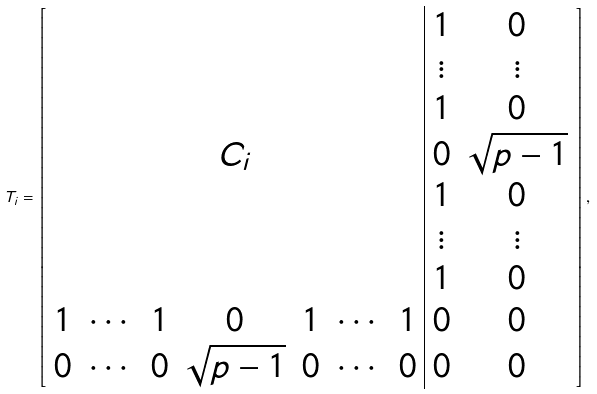Convert formula to latex. <formula><loc_0><loc_0><loc_500><loc_500>T _ { i } = \left [ \begin{array} { c c c c c c c | c c } & & & & & & & 1 & 0 \\ & & & & & & & \vdots & \vdots \\ & & & & & & & 1 & 0 \\ & & & C _ { i } & & & & 0 & \sqrt { p - 1 } \\ & & & & & & & 1 & 0 \\ & & & & & & & \vdots & \vdots \\ & & & & & & & 1 & 0 \\ 1 & \cdots & 1 & 0 & 1 & \cdots & 1 & 0 & 0 \\ 0 & \cdots & 0 & \sqrt { p - 1 } & 0 & \cdots & 0 & 0 & 0 \end{array} \right ] ,</formula> 